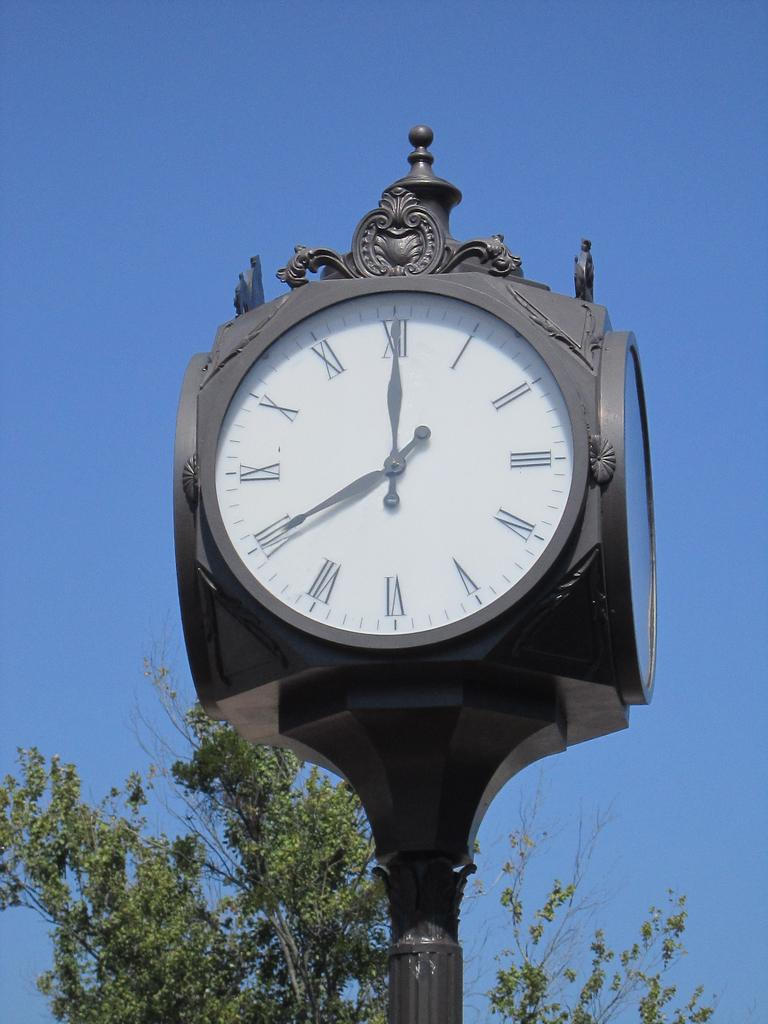<image>
Write a terse but informative summary of the picture. A clock has a Roman numeral number XII at the top of the face. 